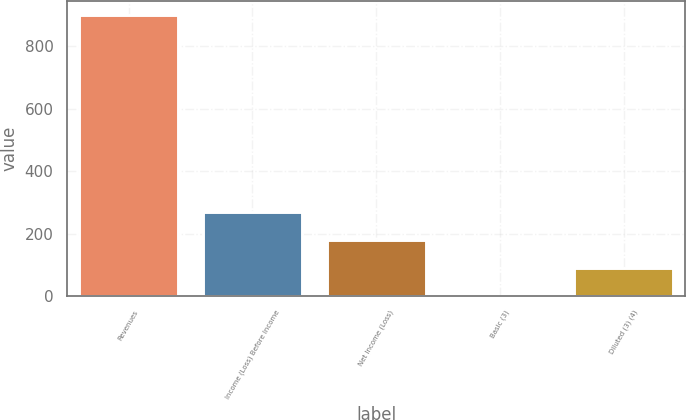Convert chart to OTSL. <chart><loc_0><loc_0><loc_500><loc_500><bar_chart><fcel>Revenues<fcel>Income (Loss) Before Income<fcel>Net Income (Loss)<fcel>Basic (3)<fcel>Diluted (3) (4)<nl><fcel>899<fcel>269.75<fcel>179.86<fcel>0.08<fcel>89.97<nl></chart> 